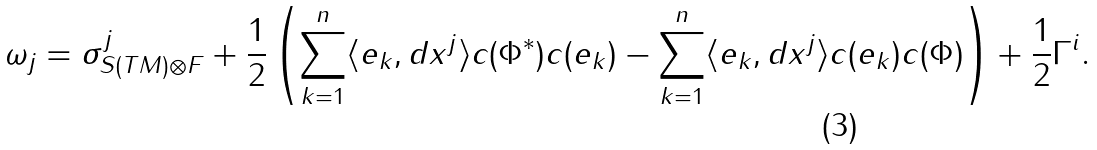<formula> <loc_0><loc_0><loc_500><loc_500>\omega _ { j } = \sigma ^ { j } _ { S ( T M ) \otimes F } + \frac { 1 } { 2 } \left ( \sum _ { k = 1 } ^ { n } \langle e _ { k } , d x ^ { j } \rangle c ( \Phi ^ { * } ) c ( e _ { k } ) - \sum _ { k = 1 } ^ { n } \langle e _ { k } , d x ^ { j } \rangle c ( e _ { k } ) c ( \Phi ) \right ) + \frac { 1 } { 2 } \Gamma ^ { i } .</formula> 